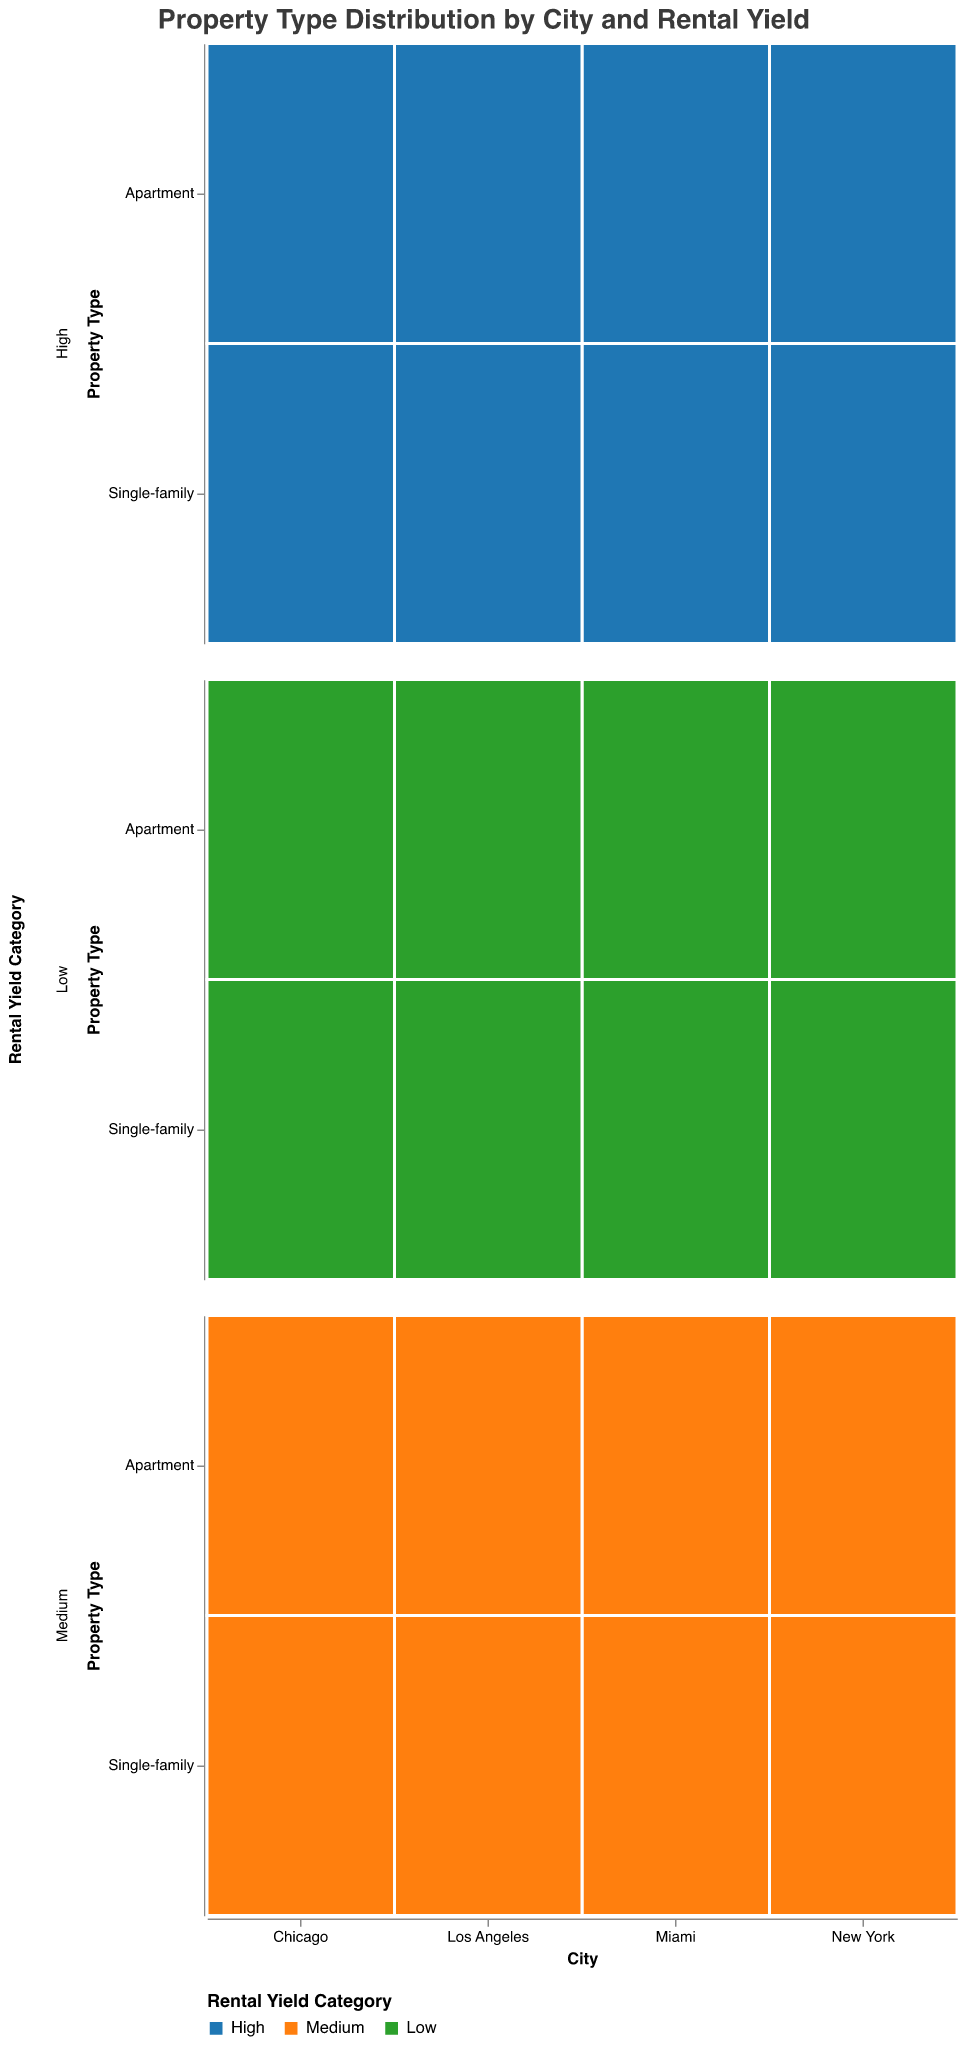What is the overall trend in the count of high rental yield apartments across the four cities? By visually inspecting the figure, we can observe that the counts of high rental yield apartments are as follows: New York (120), Chicago (80), Miami (100), and Los Angeles (110). The counts are somewhat similar with New York having slightly more than the other cities, followed by Los Angeles, then Miami, and lastly Chicago.
Answer: New York > Los Angeles > Miami > Chicago Which city has the highest number of medium rental yield single-family properties? To find the city with the highest number of medium rental yield single-family properties, we look at the counts for each city: New York (90), Chicago (110), Miami (120), and Los Angeles (100). Miami has the highest number.
Answer: Miami Are there more high rental yield single-family properties in Miami or Chicago? Comparing the counts of high rental yield single-family properties, Miami has 70 while Chicago has 60. Therefore, Miami has more.
Answer: Miami What is the total number of low rental yield properties in New York? Adding the counts of low rental yield properties in New York: Apartments (60) and Single-family (30), we get a total of 90.
Answer: 90 Compare the number of high rental yield apartments to high rental yield single-family properties in Los Angeles. Which is higher and by how much? In Los Angeles, there are 110 high rental yield apartments and 65 high rental yield single-family properties. The difference is 110 - 65 = 45. Thus, there are 45 more high rental yield apartments than single-family properties.
Answer: Apartments by 45 Which property type and rental yield category combination is the least common in Chicago? To determine the least common combination in Chicago, we examine the counts: Apartments (High: 80, Medium: 150, Low: 50) and Single-family (High: 60, Medium: 110, Low: 40). The least common combination is Single-family with a low rental yield, at 40.
Answer: Single-family, Low How does the count of medium rental yield properties compare between Miami and New York for single-family homes? In Miami, there are 120 medium rental yield single-family properties, while in New York there are 90. Miami has 30 more medium rental yield single-family properties than New York.
Answer: Miami by 30 